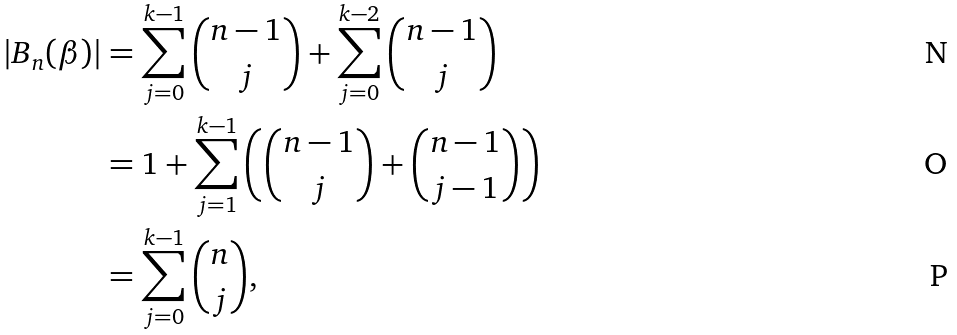Convert formula to latex. <formula><loc_0><loc_0><loc_500><loc_500>| B _ { n } ( \beta ) | & = \sum _ { j = 0 } ^ { k - 1 } \binom { n - 1 } { j } + \sum _ { j = 0 } ^ { k - 2 } \binom { n - 1 } { j } \\ & = 1 + \sum _ { j = 1 } ^ { k - 1 } \left ( \binom { n - 1 } { j } + \binom { n - 1 } { j - 1 } \right ) \\ & = \sum _ { j = 0 } ^ { k - 1 } \binom { n } { j } ,</formula> 